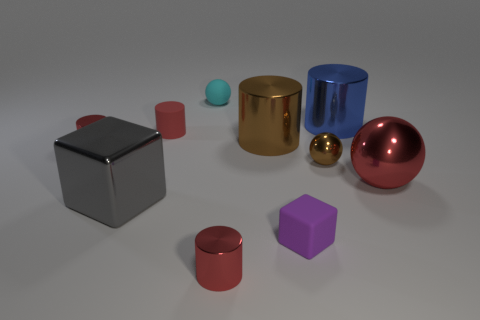Subtract all gray cubes. How many red cylinders are left? 3 Subtract all brown cylinders. How many cylinders are left? 4 Subtract all blue cylinders. How many cylinders are left? 4 Subtract all cyan cylinders. Subtract all yellow cubes. How many cylinders are left? 5 Subtract all blocks. How many objects are left? 8 Add 4 big brown metal cylinders. How many big brown metal cylinders are left? 5 Add 3 small metallic cylinders. How many small metallic cylinders exist? 5 Subtract 1 red spheres. How many objects are left? 9 Subtract all big yellow metallic spheres. Subtract all large spheres. How many objects are left? 9 